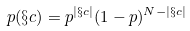Convert formula to latex. <formula><loc_0><loc_0><loc_500><loc_500>p ( \S c ) = p ^ { | \S c | } ( 1 - p ) ^ { N - | \S c | }</formula> 